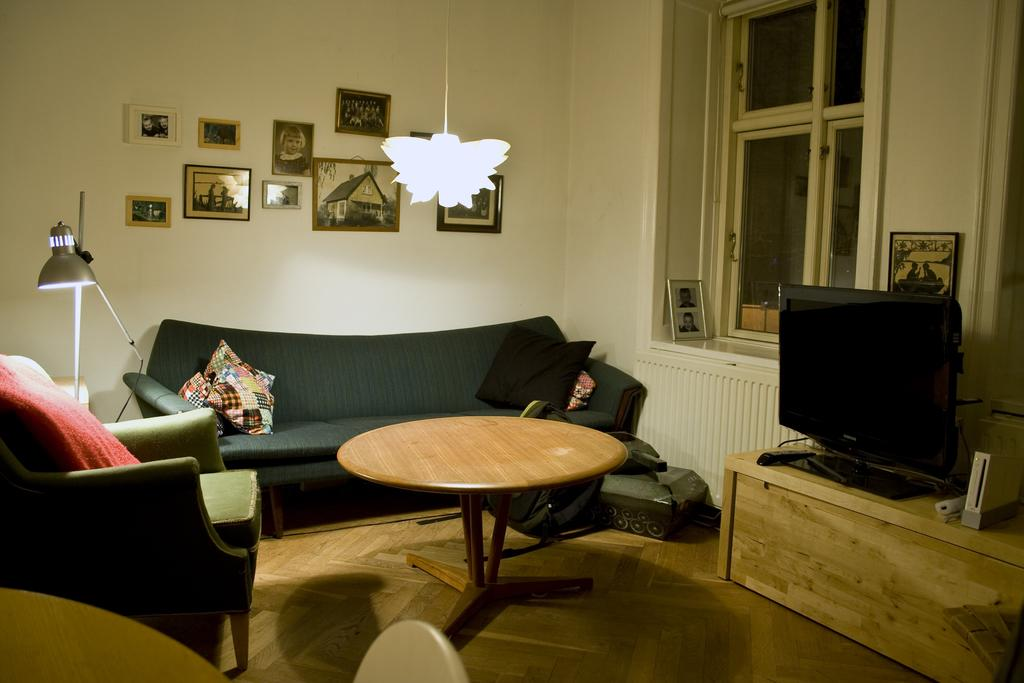What type of furniture is in the room? There is a sofa in the room. What type of entertainment device is in the room? There is a TV in the room. What type of lighting is in the room? There is a lamp in the room. What type of table is in the room? There is a table with photo frames in the room. What type of decoration is on the wall? There are items on the wall. What type of lighting fixture is hanging in the room? There is a chandelier hanging in the room. What type of father is depicted in the photo frames on the table? There is no father depicted in the photo frames on the table; they contain images of people or objects. What type of beast is lurking in the corner of the room? There is no beast present in the room; the image only shows furniture, a TV, a lamp, a table with photo frames, items on the wall, and a chandelier. 